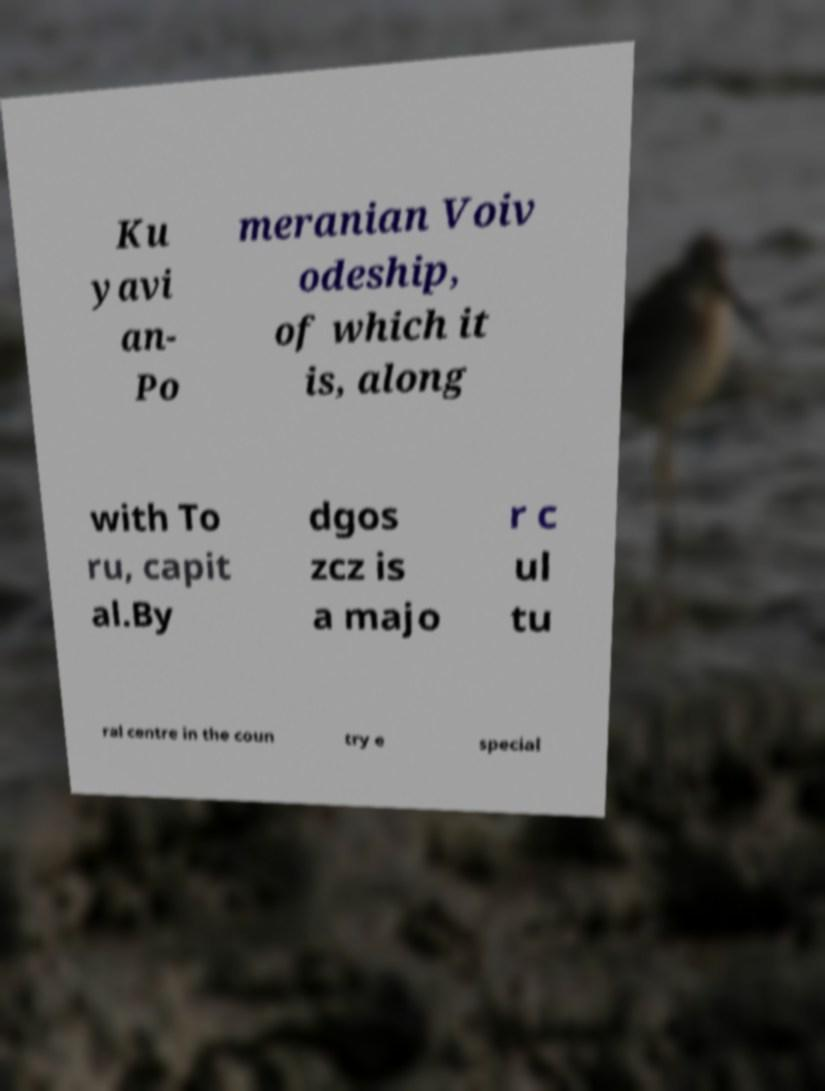Please identify and transcribe the text found in this image. Ku yavi an- Po meranian Voiv odeship, of which it is, along with To ru, capit al.By dgos zcz is a majo r c ul tu ral centre in the coun try e special 